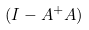<formula> <loc_0><loc_0><loc_500><loc_500>( I - A ^ { + } A )</formula> 